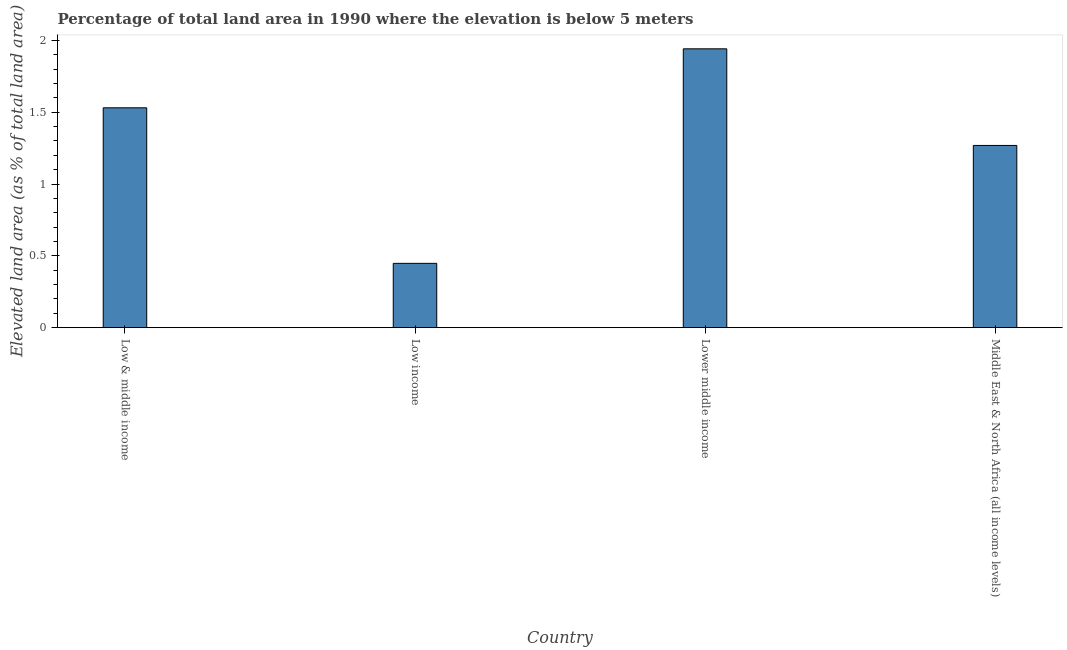Does the graph contain any zero values?
Offer a terse response. No. What is the title of the graph?
Provide a short and direct response. Percentage of total land area in 1990 where the elevation is below 5 meters. What is the label or title of the Y-axis?
Your answer should be very brief. Elevated land area (as % of total land area). What is the total elevated land area in Low income?
Your answer should be compact. 0.45. Across all countries, what is the maximum total elevated land area?
Keep it short and to the point. 1.94. Across all countries, what is the minimum total elevated land area?
Your response must be concise. 0.45. In which country was the total elevated land area maximum?
Provide a short and direct response. Lower middle income. In which country was the total elevated land area minimum?
Offer a very short reply. Low income. What is the sum of the total elevated land area?
Keep it short and to the point. 5.19. What is the difference between the total elevated land area in Low income and Lower middle income?
Make the answer very short. -1.49. What is the average total elevated land area per country?
Provide a succinct answer. 1.3. What is the median total elevated land area?
Provide a short and direct response. 1.4. In how many countries, is the total elevated land area greater than 0.6 %?
Keep it short and to the point. 3. What is the ratio of the total elevated land area in Low & middle income to that in Middle East & North Africa (all income levels)?
Ensure brevity in your answer.  1.21. Is the total elevated land area in Lower middle income less than that in Middle East & North Africa (all income levels)?
Offer a terse response. No. What is the difference between the highest and the second highest total elevated land area?
Your answer should be very brief. 0.41. What is the difference between the highest and the lowest total elevated land area?
Offer a terse response. 1.49. In how many countries, is the total elevated land area greater than the average total elevated land area taken over all countries?
Offer a terse response. 2. Are all the bars in the graph horizontal?
Provide a short and direct response. No. What is the Elevated land area (as % of total land area) in Low & middle income?
Provide a short and direct response. 1.53. What is the Elevated land area (as % of total land area) in Low income?
Your answer should be very brief. 0.45. What is the Elevated land area (as % of total land area) in Lower middle income?
Provide a succinct answer. 1.94. What is the Elevated land area (as % of total land area) in Middle East & North Africa (all income levels)?
Ensure brevity in your answer.  1.27. What is the difference between the Elevated land area (as % of total land area) in Low & middle income and Low income?
Provide a short and direct response. 1.08. What is the difference between the Elevated land area (as % of total land area) in Low & middle income and Lower middle income?
Offer a very short reply. -0.41. What is the difference between the Elevated land area (as % of total land area) in Low & middle income and Middle East & North Africa (all income levels)?
Make the answer very short. 0.26. What is the difference between the Elevated land area (as % of total land area) in Low income and Lower middle income?
Ensure brevity in your answer.  -1.49. What is the difference between the Elevated land area (as % of total land area) in Low income and Middle East & North Africa (all income levels)?
Give a very brief answer. -0.82. What is the difference between the Elevated land area (as % of total land area) in Lower middle income and Middle East & North Africa (all income levels)?
Offer a very short reply. 0.67. What is the ratio of the Elevated land area (as % of total land area) in Low & middle income to that in Low income?
Make the answer very short. 3.42. What is the ratio of the Elevated land area (as % of total land area) in Low & middle income to that in Lower middle income?
Ensure brevity in your answer.  0.79. What is the ratio of the Elevated land area (as % of total land area) in Low & middle income to that in Middle East & North Africa (all income levels)?
Give a very brief answer. 1.21. What is the ratio of the Elevated land area (as % of total land area) in Low income to that in Lower middle income?
Provide a short and direct response. 0.23. What is the ratio of the Elevated land area (as % of total land area) in Low income to that in Middle East & North Africa (all income levels)?
Make the answer very short. 0.35. What is the ratio of the Elevated land area (as % of total land area) in Lower middle income to that in Middle East & North Africa (all income levels)?
Your answer should be compact. 1.53. 